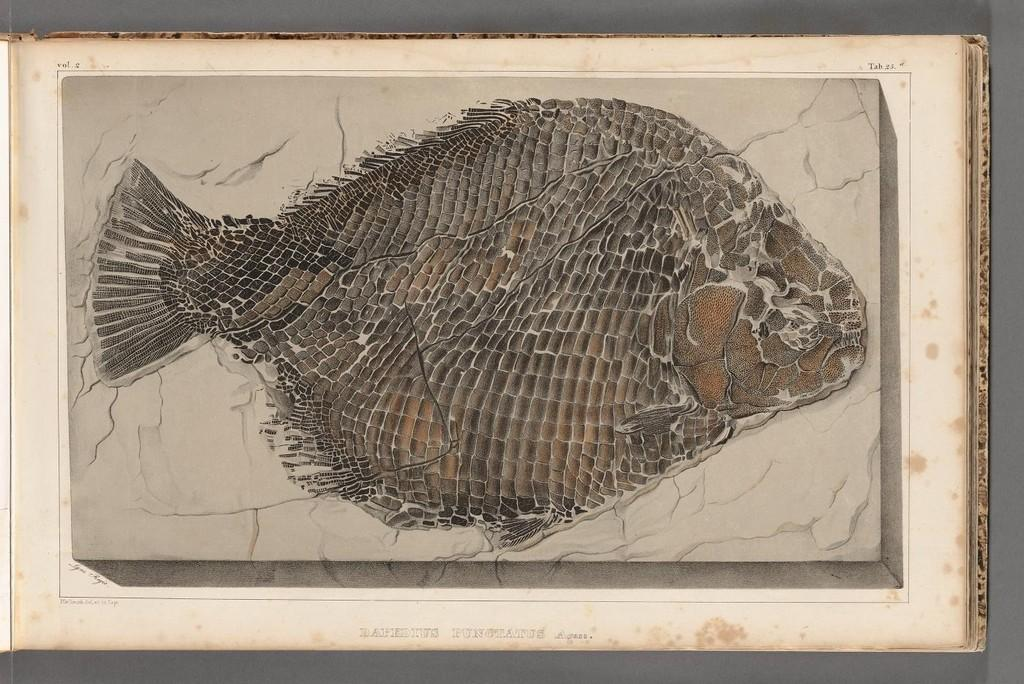What type of animal is in the image? There is a fish in the image. What colors can be seen on the fish? The fish has black, brown, and grey colors. What colors are used in the background of the image? The background of the image is in cream and white colors. What type of industry can be seen in the background of the image? There is no industry present in the image; the background is in cream and white colors. Is there a dog in the image? No, there is no dog present in the image; the main subject is a fish. 